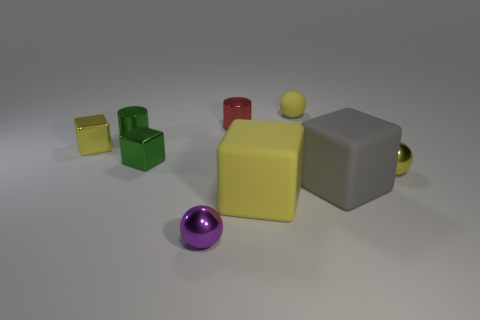Subtract all yellow spheres. How many were subtracted if there are1yellow spheres left? 1 Subtract all green metallic cubes. How many cubes are left? 3 Subtract all green blocks. How many blocks are left? 3 Subtract all cyan cubes. Subtract all yellow cylinders. How many cubes are left? 4 Subtract 0 blue cylinders. How many objects are left? 9 Subtract all cylinders. How many objects are left? 7 Subtract all small matte balls. Subtract all yellow rubber things. How many objects are left? 6 Add 6 tiny rubber spheres. How many tiny rubber spheres are left? 7 Add 5 gray matte blocks. How many gray matte blocks exist? 6 